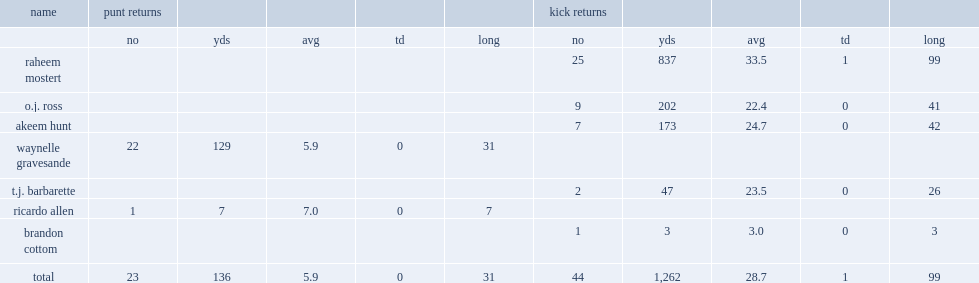How many yards did raheem mostert average a return? 33.5. 